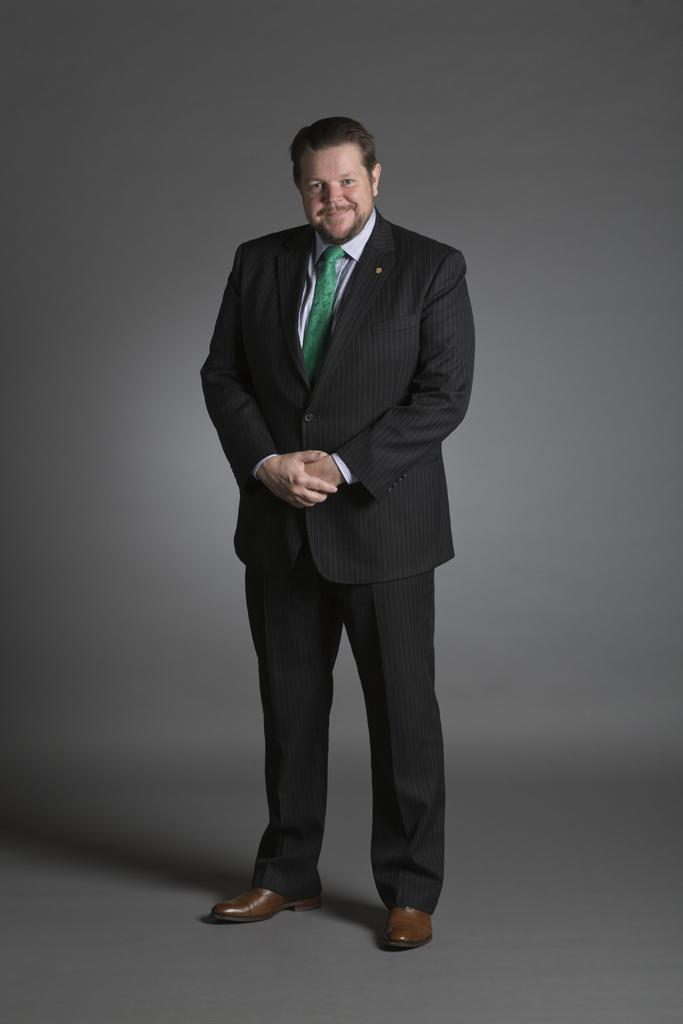What is present in the center of the image? There is a man in the image, and he is located in the center of the image. What is the man's position in relation to the ground? The man is standing on the ground. What type of writing can be seen on the owl in the image? There is no owl present in the image, and therefore no writing can be observed on it. 